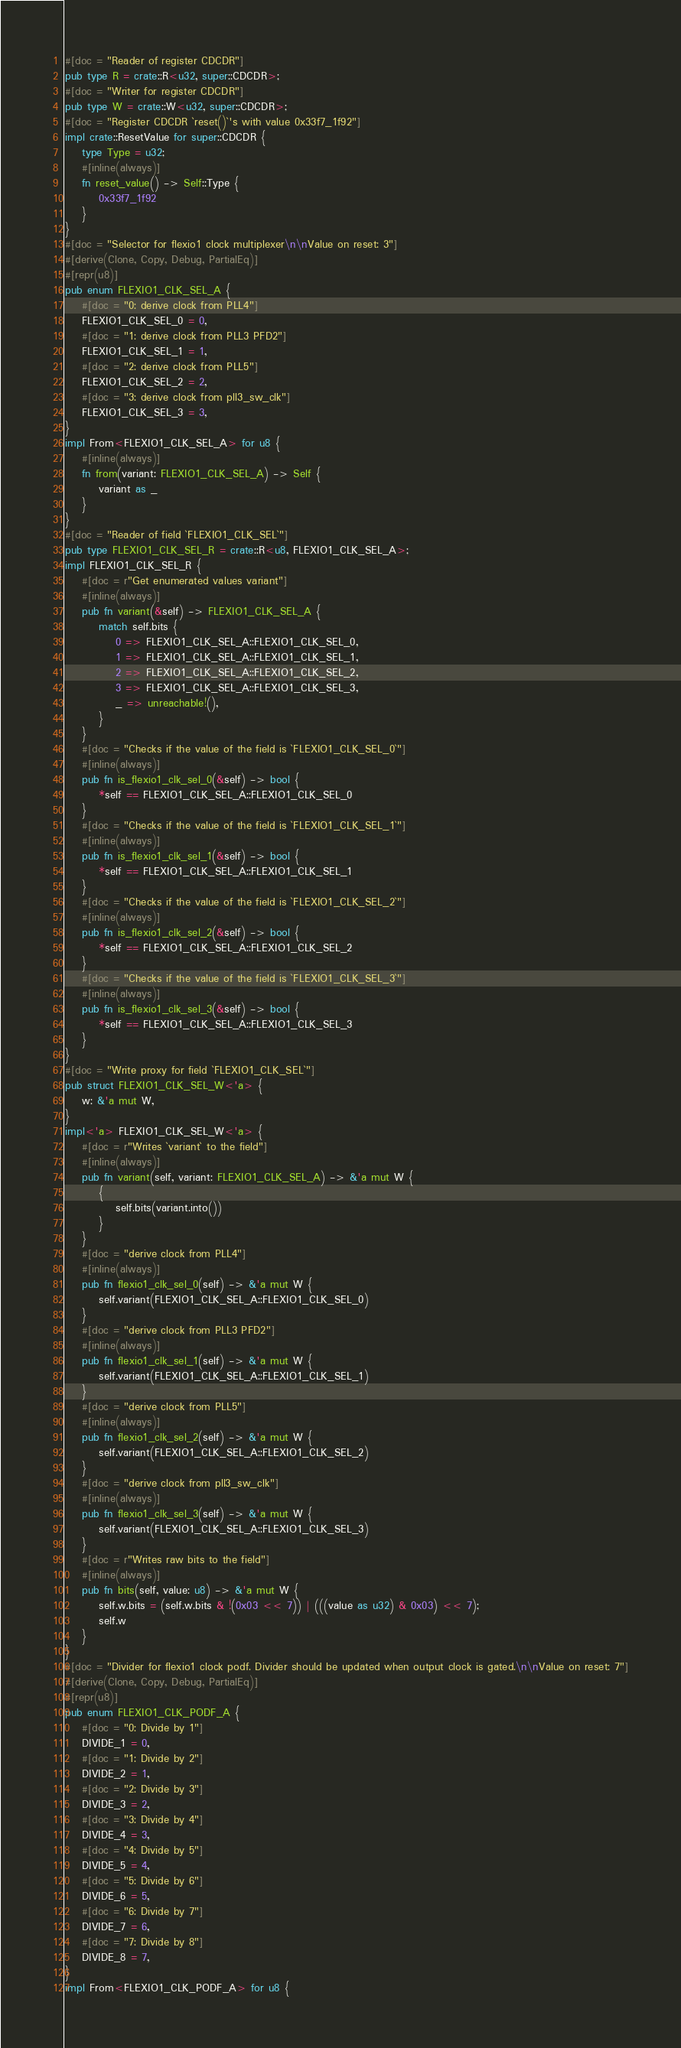<code> <loc_0><loc_0><loc_500><loc_500><_Rust_>#[doc = "Reader of register CDCDR"]
pub type R = crate::R<u32, super::CDCDR>;
#[doc = "Writer for register CDCDR"]
pub type W = crate::W<u32, super::CDCDR>;
#[doc = "Register CDCDR `reset()`'s with value 0x33f7_1f92"]
impl crate::ResetValue for super::CDCDR {
    type Type = u32;
    #[inline(always)]
    fn reset_value() -> Self::Type {
        0x33f7_1f92
    }
}
#[doc = "Selector for flexio1 clock multiplexer\n\nValue on reset: 3"]
#[derive(Clone, Copy, Debug, PartialEq)]
#[repr(u8)]
pub enum FLEXIO1_CLK_SEL_A {
    #[doc = "0: derive clock from PLL4"]
    FLEXIO1_CLK_SEL_0 = 0,
    #[doc = "1: derive clock from PLL3 PFD2"]
    FLEXIO1_CLK_SEL_1 = 1,
    #[doc = "2: derive clock from PLL5"]
    FLEXIO1_CLK_SEL_2 = 2,
    #[doc = "3: derive clock from pll3_sw_clk"]
    FLEXIO1_CLK_SEL_3 = 3,
}
impl From<FLEXIO1_CLK_SEL_A> for u8 {
    #[inline(always)]
    fn from(variant: FLEXIO1_CLK_SEL_A) -> Self {
        variant as _
    }
}
#[doc = "Reader of field `FLEXIO1_CLK_SEL`"]
pub type FLEXIO1_CLK_SEL_R = crate::R<u8, FLEXIO1_CLK_SEL_A>;
impl FLEXIO1_CLK_SEL_R {
    #[doc = r"Get enumerated values variant"]
    #[inline(always)]
    pub fn variant(&self) -> FLEXIO1_CLK_SEL_A {
        match self.bits {
            0 => FLEXIO1_CLK_SEL_A::FLEXIO1_CLK_SEL_0,
            1 => FLEXIO1_CLK_SEL_A::FLEXIO1_CLK_SEL_1,
            2 => FLEXIO1_CLK_SEL_A::FLEXIO1_CLK_SEL_2,
            3 => FLEXIO1_CLK_SEL_A::FLEXIO1_CLK_SEL_3,
            _ => unreachable!(),
        }
    }
    #[doc = "Checks if the value of the field is `FLEXIO1_CLK_SEL_0`"]
    #[inline(always)]
    pub fn is_flexio1_clk_sel_0(&self) -> bool {
        *self == FLEXIO1_CLK_SEL_A::FLEXIO1_CLK_SEL_0
    }
    #[doc = "Checks if the value of the field is `FLEXIO1_CLK_SEL_1`"]
    #[inline(always)]
    pub fn is_flexio1_clk_sel_1(&self) -> bool {
        *self == FLEXIO1_CLK_SEL_A::FLEXIO1_CLK_SEL_1
    }
    #[doc = "Checks if the value of the field is `FLEXIO1_CLK_SEL_2`"]
    #[inline(always)]
    pub fn is_flexio1_clk_sel_2(&self) -> bool {
        *self == FLEXIO1_CLK_SEL_A::FLEXIO1_CLK_SEL_2
    }
    #[doc = "Checks if the value of the field is `FLEXIO1_CLK_SEL_3`"]
    #[inline(always)]
    pub fn is_flexio1_clk_sel_3(&self) -> bool {
        *self == FLEXIO1_CLK_SEL_A::FLEXIO1_CLK_SEL_3
    }
}
#[doc = "Write proxy for field `FLEXIO1_CLK_SEL`"]
pub struct FLEXIO1_CLK_SEL_W<'a> {
    w: &'a mut W,
}
impl<'a> FLEXIO1_CLK_SEL_W<'a> {
    #[doc = r"Writes `variant` to the field"]
    #[inline(always)]
    pub fn variant(self, variant: FLEXIO1_CLK_SEL_A) -> &'a mut W {
        {
            self.bits(variant.into())
        }
    }
    #[doc = "derive clock from PLL4"]
    #[inline(always)]
    pub fn flexio1_clk_sel_0(self) -> &'a mut W {
        self.variant(FLEXIO1_CLK_SEL_A::FLEXIO1_CLK_SEL_0)
    }
    #[doc = "derive clock from PLL3 PFD2"]
    #[inline(always)]
    pub fn flexio1_clk_sel_1(self) -> &'a mut W {
        self.variant(FLEXIO1_CLK_SEL_A::FLEXIO1_CLK_SEL_1)
    }
    #[doc = "derive clock from PLL5"]
    #[inline(always)]
    pub fn flexio1_clk_sel_2(self) -> &'a mut W {
        self.variant(FLEXIO1_CLK_SEL_A::FLEXIO1_CLK_SEL_2)
    }
    #[doc = "derive clock from pll3_sw_clk"]
    #[inline(always)]
    pub fn flexio1_clk_sel_3(self) -> &'a mut W {
        self.variant(FLEXIO1_CLK_SEL_A::FLEXIO1_CLK_SEL_3)
    }
    #[doc = r"Writes raw bits to the field"]
    #[inline(always)]
    pub fn bits(self, value: u8) -> &'a mut W {
        self.w.bits = (self.w.bits & !(0x03 << 7)) | (((value as u32) & 0x03) << 7);
        self.w
    }
}
#[doc = "Divider for flexio1 clock podf. Divider should be updated when output clock is gated.\n\nValue on reset: 7"]
#[derive(Clone, Copy, Debug, PartialEq)]
#[repr(u8)]
pub enum FLEXIO1_CLK_PODF_A {
    #[doc = "0: Divide by 1"]
    DIVIDE_1 = 0,
    #[doc = "1: Divide by 2"]
    DIVIDE_2 = 1,
    #[doc = "2: Divide by 3"]
    DIVIDE_3 = 2,
    #[doc = "3: Divide by 4"]
    DIVIDE_4 = 3,
    #[doc = "4: Divide by 5"]
    DIVIDE_5 = 4,
    #[doc = "5: Divide by 6"]
    DIVIDE_6 = 5,
    #[doc = "6: Divide by 7"]
    DIVIDE_7 = 6,
    #[doc = "7: Divide by 8"]
    DIVIDE_8 = 7,
}
impl From<FLEXIO1_CLK_PODF_A> for u8 {</code> 